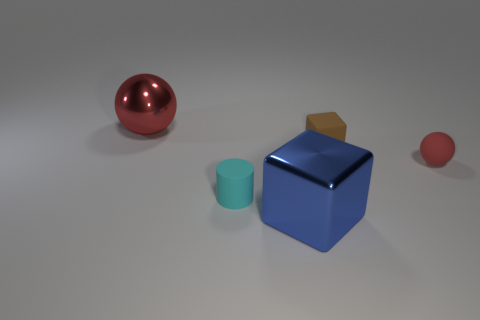There is a cube that is the same material as the large red object; what is its size?
Ensure brevity in your answer.  Large. What number of small matte cylinders are the same color as the large ball?
Provide a succinct answer. 0. There is a block behind the cyan cylinder; is its size the same as the small cyan matte object?
Offer a terse response. Yes. What is the color of the matte thing that is in front of the brown object and left of the tiny red ball?
Offer a terse response. Cyan. How many objects are green cylinders or shiny objects that are to the left of the matte cylinder?
Offer a terse response. 1. What is the material of the big object that is behind the ball right of the block that is in front of the cylinder?
Ensure brevity in your answer.  Metal. There is a block behind the tiny rubber sphere; is it the same color as the tiny cylinder?
Provide a succinct answer. No. How many blue objects are either big objects or metallic balls?
Give a very brief answer. 1. How many other things are the same shape as the small red rubber thing?
Your response must be concise. 1. Do the tiny cyan object and the small red sphere have the same material?
Your response must be concise. Yes. 